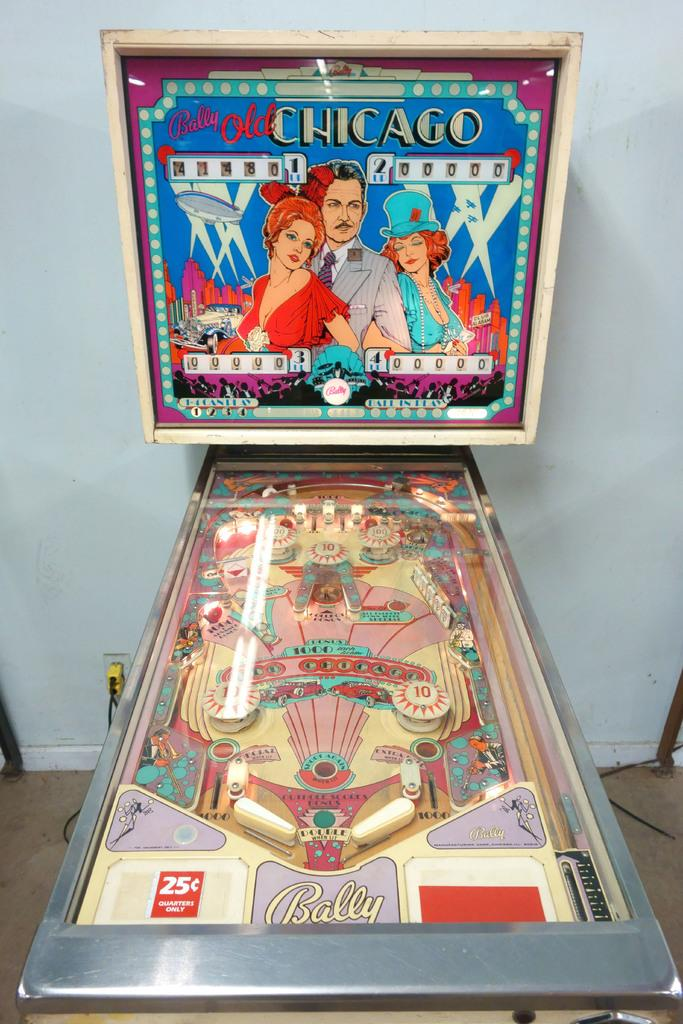What type of game is on the floor in the image? There is a pinball game on the floor. What color is the wall in the background? The wall in the background is white-colored. What can be seen in the background besides the wall? There are wires visible in the background. What might be used to power the pinball game in the image? There is an electric socket in the background that could be used to power the pinball game. Can you tell me what animals are arguing in the background of the image? There are no animals or arguments present in the image; it features a pinball game on the floor and a white-colored wall with wires and an electric socket in the background. 